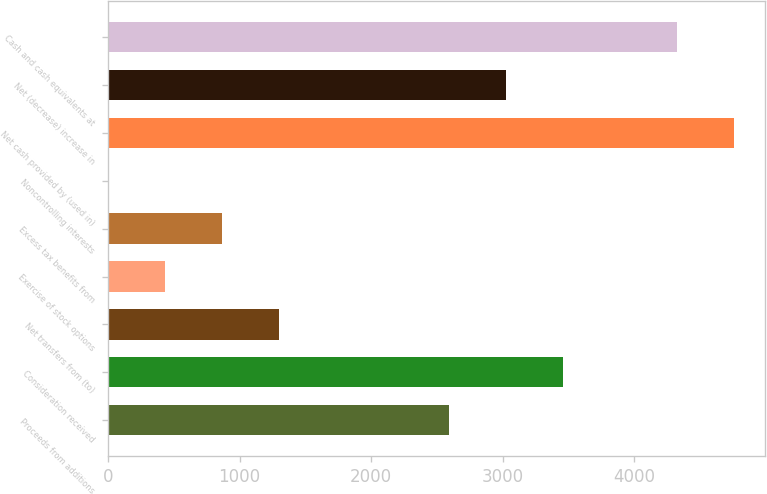Convert chart. <chart><loc_0><loc_0><loc_500><loc_500><bar_chart><fcel>Proceeds from additions<fcel>Consideration received<fcel>Net transfers from (to)<fcel>Exercise of stock options<fcel>Excess tax benefits from<fcel>Noncontrolling interests<fcel>Net cash provided by (used in)<fcel>Net (decrease) increase in<fcel>Cash and cash equivalents at<nl><fcel>2595.8<fcel>3459.4<fcel>1300.4<fcel>436.8<fcel>868.6<fcel>5<fcel>4754.8<fcel>3027.6<fcel>4323<nl></chart> 